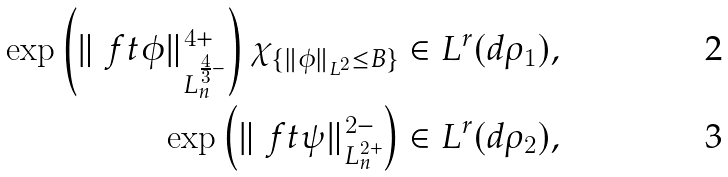Convert formula to latex. <formula><loc_0><loc_0><loc_500><loc_500>\exp \left ( { \| \ f t { \phi } \| _ { L _ { n } ^ { \frac { 4 } { 3 } - } } ^ { 4 + } } \right ) \chi _ { \{ \| \phi \| _ { L ^ { 2 } } \leq B \} } & \in L ^ { r } ( d \rho _ { 1 } ) , \\ \exp \left ( { \| \ f t { \psi } \| _ { L _ { n } ^ { 2 + } } ^ { 2 - } } \right ) & \in L ^ { r } ( d \rho _ { 2 } ) ,</formula> 